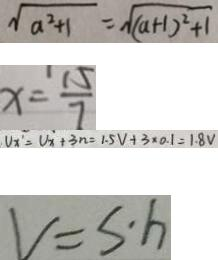Convert formula to latex. <formula><loc_0><loc_0><loc_500><loc_500>\sqrt { a ^ { 2 } + 1 } = \sqrt { ( a + 1 ) ^ { 2 } + 1 } 
 x = \frac { 1 5 } { 7 } 
 V _ { x ^ { \prime } } = V _ { x } + 3 n = 1 . 5 V + 3 \times 0 . 1 = 1 . 8 V 
 V = s \cdot h</formula> 